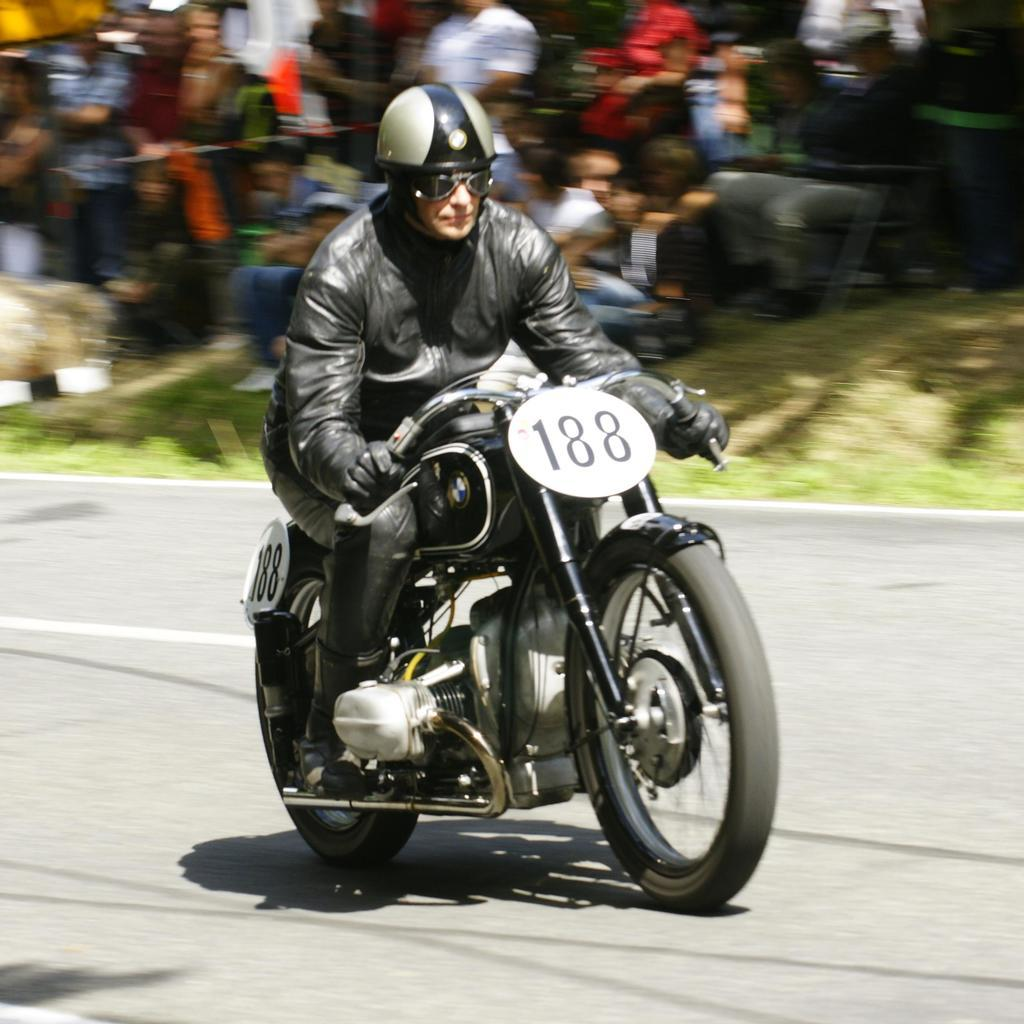What is the person in the image doing? There is a person riding a bike in the image. What is the person wearing while riding the bike? The person is wearing a black coat and a helmet. What can be seen on the bike? The bike has the name "188". What is visible in the background of the image? There are spectators in the background of the image. How does the person react to the bag in the image? There is no bag present in the image, so the person's reaction cannot be determined. 